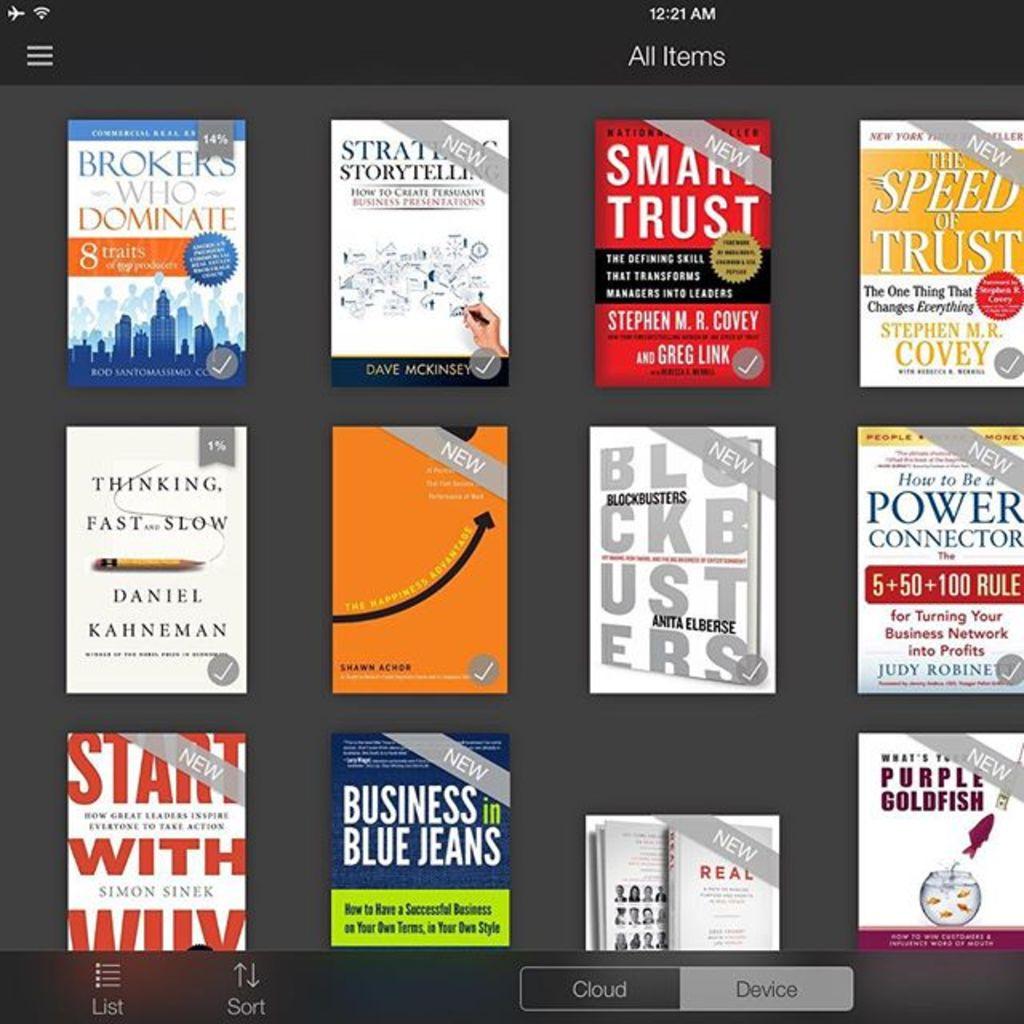Who wrote the book on the top right?
Make the answer very short. Stephen m.r. covey. 